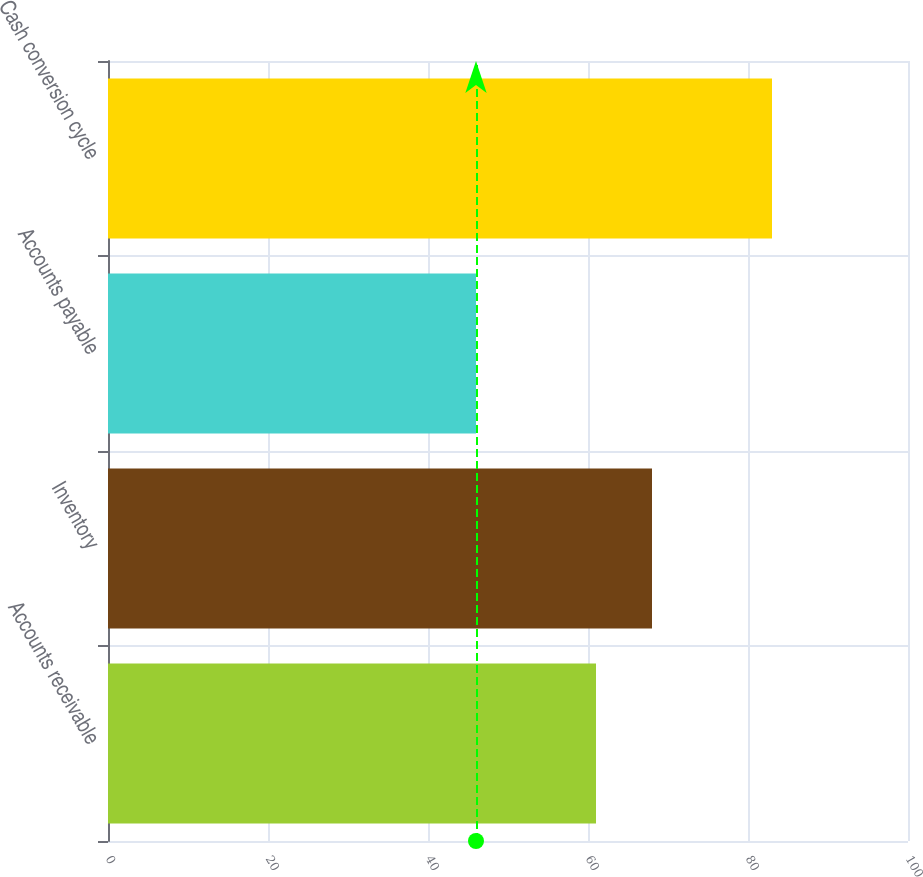Convert chart. <chart><loc_0><loc_0><loc_500><loc_500><bar_chart><fcel>Accounts receivable<fcel>Inventory<fcel>Accounts payable<fcel>Cash conversion cycle<nl><fcel>61<fcel>68<fcel>46<fcel>83<nl></chart> 